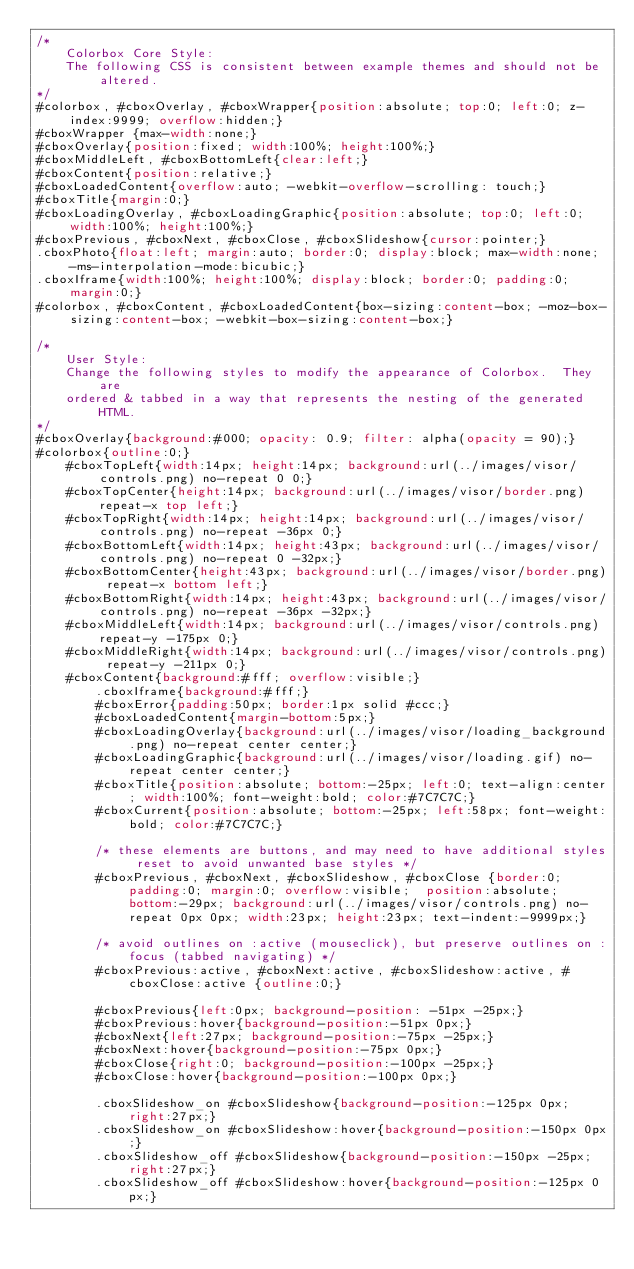<code> <loc_0><loc_0><loc_500><loc_500><_CSS_>/*
    Colorbox Core Style:
    The following CSS is consistent between example themes and should not be altered.
*/
#colorbox, #cboxOverlay, #cboxWrapper{position:absolute; top:0; left:0; z-index:9999; overflow:hidden;}
#cboxWrapper {max-width:none;}
#cboxOverlay{position:fixed; width:100%; height:100%;}
#cboxMiddleLeft, #cboxBottomLeft{clear:left;}
#cboxContent{position:relative;}
#cboxLoadedContent{overflow:auto; -webkit-overflow-scrolling: touch;}
#cboxTitle{margin:0;}
#cboxLoadingOverlay, #cboxLoadingGraphic{position:absolute; top:0; left:0; width:100%; height:100%;}
#cboxPrevious, #cboxNext, #cboxClose, #cboxSlideshow{cursor:pointer;}
.cboxPhoto{float:left; margin:auto; border:0; display:block; max-width:none; -ms-interpolation-mode:bicubic;}
.cboxIframe{width:100%; height:100%; display:block; border:0; padding:0; margin:0;}
#colorbox, #cboxContent, #cboxLoadedContent{box-sizing:content-box; -moz-box-sizing:content-box; -webkit-box-sizing:content-box;}

/* 
    User Style:
    Change the following styles to modify the appearance of Colorbox.  They are
    ordered & tabbed in a way that represents the nesting of the generated HTML.
*/
#cboxOverlay{background:#000; opacity: 0.9; filter: alpha(opacity = 90);}
#colorbox{outline:0;}
    #cboxTopLeft{width:14px; height:14px; background:url(../images/visor/controls.png) no-repeat 0 0;}
    #cboxTopCenter{height:14px; background:url(../images/visor/border.png) repeat-x top left;}
    #cboxTopRight{width:14px; height:14px; background:url(../images/visor/controls.png) no-repeat -36px 0;}
    #cboxBottomLeft{width:14px; height:43px; background:url(../images/visor/controls.png) no-repeat 0 -32px;}
    #cboxBottomCenter{height:43px; background:url(../images/visor/border.png) repeat-x bottom left;}
    #cboxBottomRight{width:14px; height:43px; background:url(../images/visor/controls.png) no-repeat -36px -32px;}
    #cboxMiddleLeft{width:14px; background:url(../images/visor/controls.png) repeat-y -175px 0;}
    #cboxMiddleRight{width:14px; background:url(../images/visor/controls.png) repeat-y -211px 0;}
    #cboxContent{background:#fff; overflow:visible;}
        .cboxIframe{background:#fff;}
        #cboxError{padding:50px; border:1px solid #ccc;}
        #cboxLoadedContent{margin-bottom:5px;}
        #cboxLoadingOverlay{background:url(../images/visor/loading_background.png) no-repeat center center;}
        #cboxLoadingGraphic{background:url(../images/visor/loading.gif) no-repeat center center;}
        #cboxTitle{position:absolute; bottom:-25px; left:0; text-align:center; width:100%; font-weight:bold; color:#7C7C7C;}
        #cboxCurrent{position:absolute; bottom:-25px; left:58px; font-weight:bold; color:#7C7C7C;}

        /* these elements are buttons, and may need to have additional styles reset to avoid unwanted base styles */
        #cboxPrevious, #cboxNext, #cboxSlideshow, #cboxClose {border:0; padding:0; margin:0; overflow:visible;  position:absolute; bottom:-29px; background:url(../images/visor/controls.png) no-repeat 0px 0px; width:23px; height:23px; text-indent:-9999px;}
        
        /* avoid outlines on :active (mouseclick), but preserve outlines on :focus (tabbed navigating) */
        #cboxPrevious:active, #cboxNext:active, #cboxSlideshow:active, #cboxClose:active {outline:0;}

        #cboxPrevious{left:0px; background-position: -51px -25px;}
        #cboxPrevious:hover{background-position:-51px 0px;}
        #cboxNext{left:27px; background-position:-75px -25px;}
        #cboxNext:hover{background-position:-75px 0px;}
        #cboxClose{right:0; background-position:-100px -25px;}
        #cboxClose:hover{background-position:-100px 0px;}

        .cboxSlideshow_on #cboxSlideshow{background-position:-125px 0px; right:27px;}
        .cboxSlideshow_on #cboxSlideshow:hover{background-position:-150px 0px;}
        .cboxSlideshow_off #cboxSlideshow{background-position:-150px -25px; right:27px;}
        .cboxSlideshow_off #cboxSlideshow:hover{background-position:-125px 0px;}</code> 